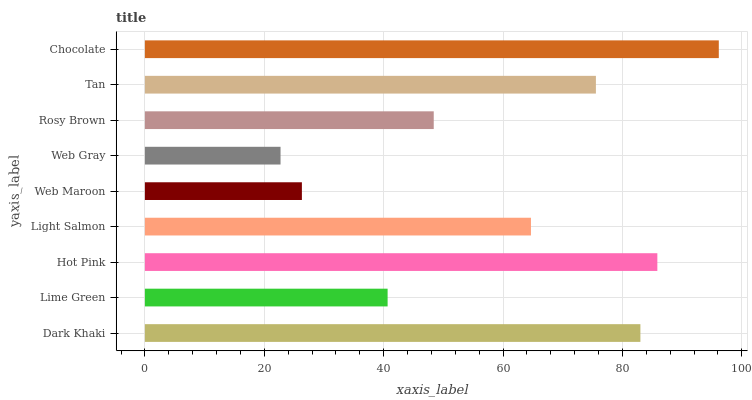Is Web Gray the minimum?
Answer yes or no. Yes. Is Chocolate the maximum?
Answer yes or no. Yes. Is Lime Green the minimum?
Answer yes or no. No. Is Lime Green the maximum?
Answer yes or no. No. Is Dark Khaki greater than Lime Green?
Answer yes or no. Yes. Is Lime Green less than Dark Khaki?
Answer yes or no. Yes. Is Lime Green greater than Dark Khaki?
Answer yes or no. No. Is Dark Khaki less than Lime Green?
Answer yes or no. No. Is Light Salmon the high median?
Answer yes or no. Yes. Is Light Salmon the low median?
Answer yes or no. Yes. Is Web Gray the high median?
Answer yes or no. No. Is Hot Pink the low median?
Answer yes or no. No. 